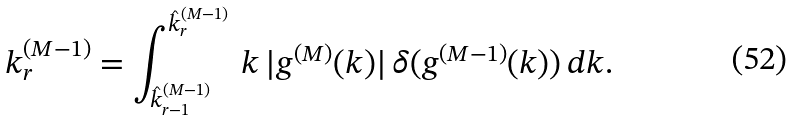Convert formula to latex. <formula><loc_0><loc_0><loc_500><loc_500>k _ { r } ^ { ( M - 1 ) } = \int _ { \hat { k } _ { r - 1 } ^ { ( M - 1 ) } } ^ { \hat { k } _ { r } ^ { ( M - 1 ) } } \, k \, | g ^ { ( M ) } ( k ) | \, \delta ( g ^ { ( M - 1 ) } ( k ) ) \, d k .</formula> 